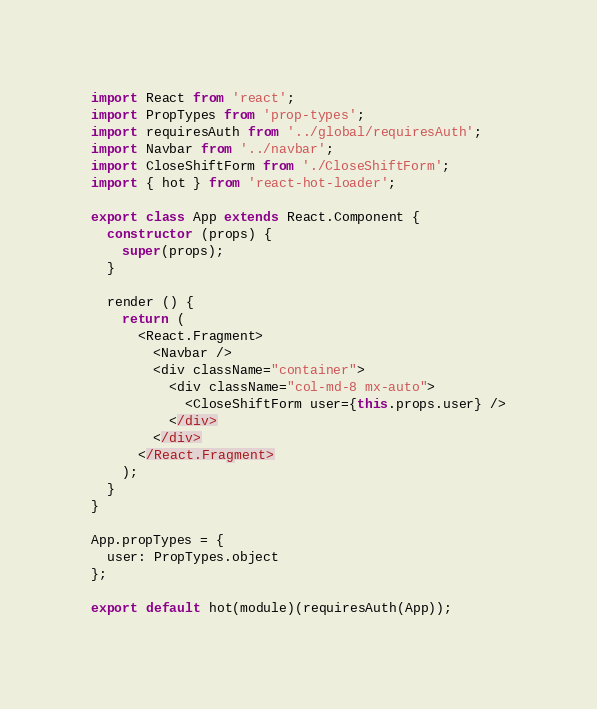Convert code to text. <code><loc_0><loc_0><loc_500><loc_500><_JavaScript_>import React from 'react';
import PropTypes from 'prop-types';
import requiresAuth from '../global/requiresAuth';
import Navbar from '../navbar';
import CloseShiftForm from './CloseShiftForm';
import { hot } from 'react-hot-loader';

export class App extends React.Component {
  constructor (props) {
    super(props);
  }

  render () {
    return (
      <React.Fragment>
        <Navbar />
        <div className="container">
          <div className="col-md-8 mx-auto">
            <CloseShiftForm user={this.props.user} />
          </div>
        </div>
      </React.Fragment>
    );
  }
}

App.propTypes = {
  user: PropTypes.object
};

export default hot(module)(requiresAuth(App));
</code> 